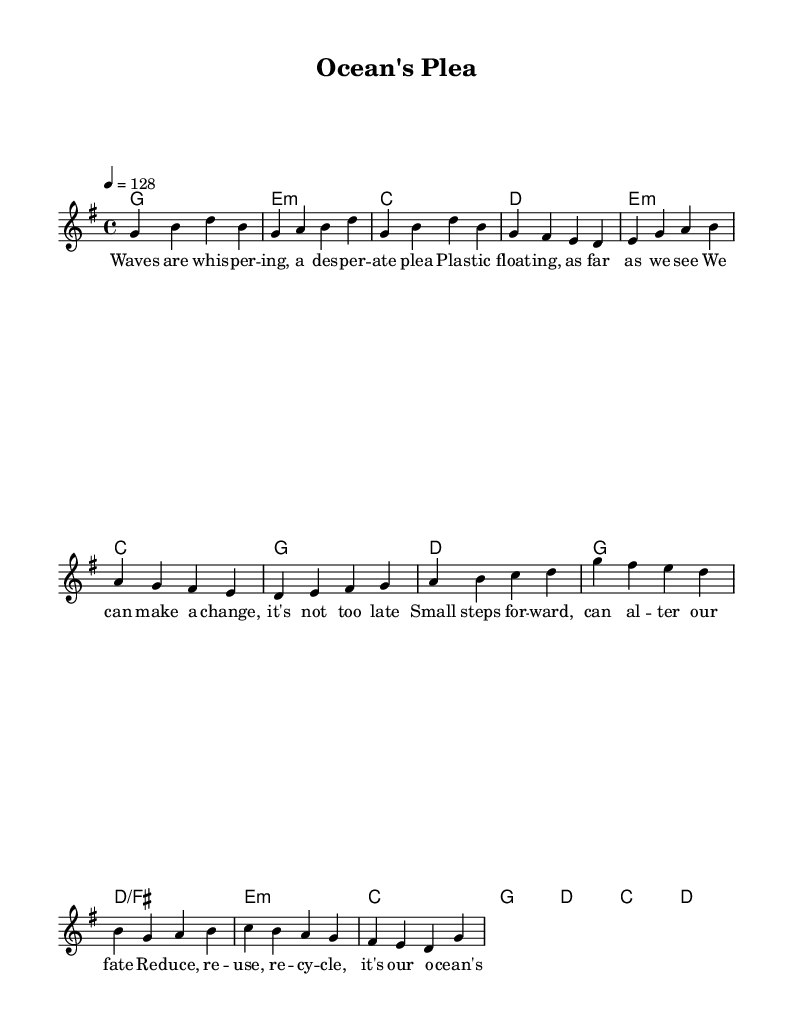What is the key signature of this music? The key signature is G major, which has one sharp (F#). This is indicated at the beginning of the sheet music, where the key signature is placed.
Answer: G major What is the time signature of this music? The time signature is 4/4, which means there are four beats in each measure and the quarter note gets one beat. This is evident in the notation at the beginning of the sheet music.
Answer: 4/4 What is the tempo marking for this piece? The tempo marking is 128 beats per minute, indicated by the number "128" along with the quarter note symbol. This provides the speed at which the music should be played.
Answer: 128 How many measures are in the verse? The verse consists of four measures as indicated by the grouping of notes and bars in the melody section. Each group of notes separated by vertical lines (bar lines) signifies one measure.
Answer: 4 What is the main message conveyed in the chorus lyrics? The chorus lyrics emphasize the concepts of reducing, reusing, and recycling, which are central to the song's theme of sustainable living. By looking at the lyrics directly, we can see these key phrases clearly highlighted.
Answer: Reduce, reuse, recycle How does the pre-chorus musically transition to the chorus? The pre-chorus ends with a rising melodic line leading into the chorus, creating anticipation. The last note of the pre-chorus leads seamlessly into the tonic chord of the chorus, establishing a forward motion.
Answer: Rising melody What type of chords are primarily used in the verse? The chords in the verse include G major, E minor, C major, and D major, all of which are common in pop music to create a bright and uplifting sound. This can be determined by analyzing the chord symbols under the melody.
Answer: G, E minor, C, D 